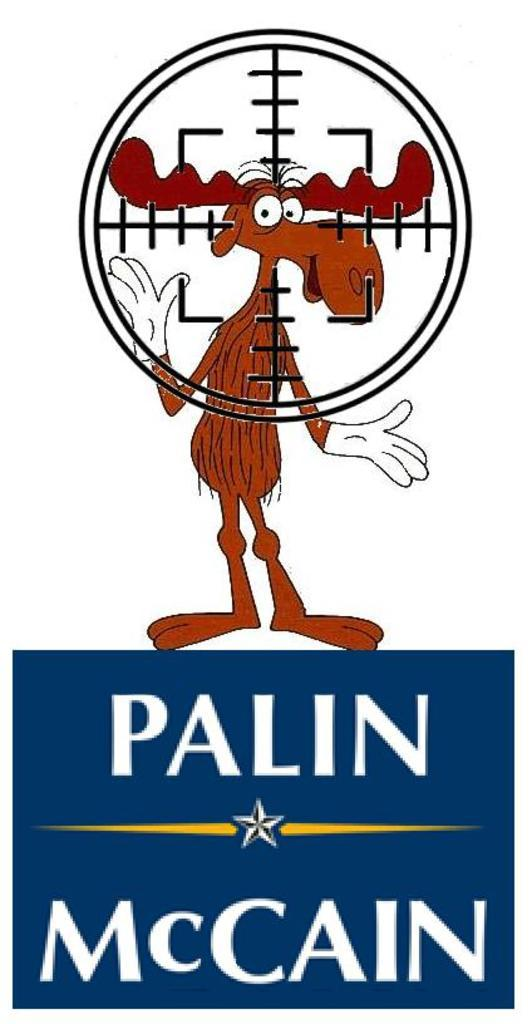<image>
Provide a brief description of the given image. A moose is on a campaign sign for Palin and McCain 